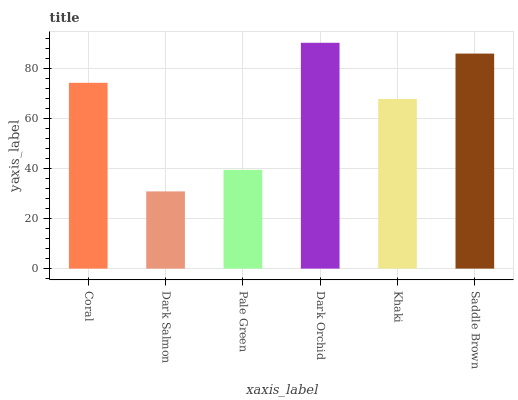Is Dark Salmon the minimum?
Answer yes or no. Yes. Is Dark Orchid the maximum?
Answer yes or no. Yes. Is Pale Green the minimum?
Answer yes or no. No. Is Pale Green the maximum?
Answer yes or no. No. Is Pale Green greater than Dark Salmon?
Answer yes or no. Yes. Is Dark Salmon less than Pale Green?
Answer yes or no. Yes. Is Dark Salmon greater than Pale Green?
Answer yes or no. No. Is Pale Green less than Dark Salmon?
Answer yes or no. No. Is Coral the high median?
Answer yes or no. Yes. Is Khaki the low median?
Answer yes or no. Yes. Is Dark Orchid the high median?
Answer yes or no. No. Is Pale Green the low median?
Answer yes or no. No. 